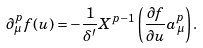Convert formula to latex. <formula><loc_0><loc_0><loc_500><loc_500>\partial _ { \mu } ^ { p } f ( u ) = - \frac { 1 } { \delta ^ { \prime } } X ^ { p - 1 } \left ( \frac { \partial f } { \partial u } a _ { \mu } ^ { p } \right ) .</formula> 